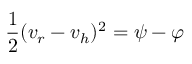Convert formula to latex. <formula><loc_0><loc_0><loc_500><loc_500>{ \frac { 1 } { 2 } } ( v _ { r } - v _ { h } ) ^ { 2 } = \psi - \varphi</formula> 